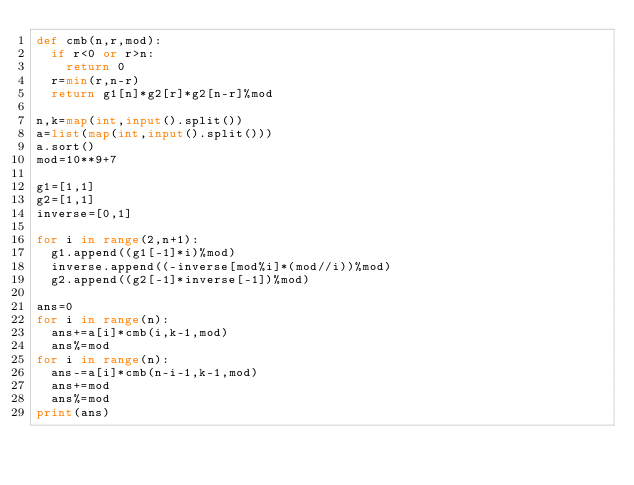<code> <loc_0><loc_0><loc_500><loc_500><_Python_>def cmb(n,r,mod):
  if r<0 or r>n:
    return 0
  r=min(r,n-r)
  return g1[n]*g2[r]*g2[n-r]%mod
 
n,k=map(int,input().split())
a=list(map(int,input().split()))
a.sort()
mod=10**9+7
 
g1=[1,1]
g2=[1,1]
inverse=[0,1]
 
for i in range(2,n+1):
  g1.append((g1[-1]*i)%mod)
  inverse.append((-inverse[mod%i]*(mod//i))%mod)
  g2.append((g2[-1]*inverse[-1])%mod)
 
ans=0
for i in range(n):
  ans+=a[i]*cmb(i,k-1,mod)
  ans%=mod
for i in range(n):
  ans-=a[i]*cmb(n-i-1,k-1,mod)
  ans+=mod
  ans%=mod
print(ans)</code> 